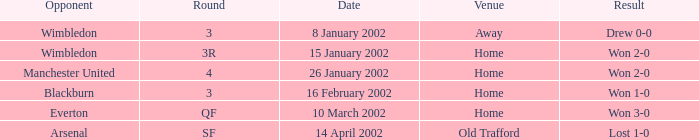What is the Round with a Opponent with blackburn? 3.0. 